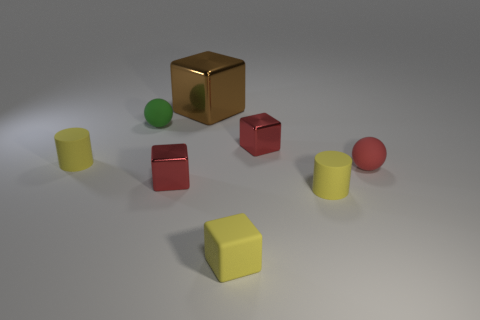Is there anything else that is the same color as the rubber block?
Your response must be concise. Yes. There is a tiny red object that is the same material as the yellow block; what is its shape?
Provide a short and direct response. Sphere. Is the number of tiny red metal things that are left of the green rubber thing less than the number of small yellow metallic objects?
Offer a terse response. No. What number of other things are the same shape as the big brown metallic thing?
Offer a very short reply. 3. What number of objects are red blocks to the left of the large block or tiny red spheres that are in front of the green thing?
Provide a short and direct response. 2. There is a metallic object that is behind the small red rubber ball and left of the yellow cube; how big is it?
Make the answer very short. Large. Does the tiny red rubber thing on the right side of the tiny green thing have the same shape as the tiny green matte thing?
Offer a very short reply. Yes. There is a shiny object behind the tiny matte sphere that is to the left of the red metal cube to the right of the yellow block; what size is it?
Make the answer very short. Large. How many things are either tiny rubber spheres or yellow objects?
Provide a short and direct response. 5. What is the shape of the tiny thing that is on the right side of the small green ball and to the left of the tiny yellow matte block?
Offer a very short reply. Cube. 